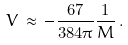<formula> <loc_0><loc_0><loc_500><loc_500>V \, \approx \, - \frac { 6 7 } { 3 8 4 \pi } \frac { 1 } { M } \, .</formula> 